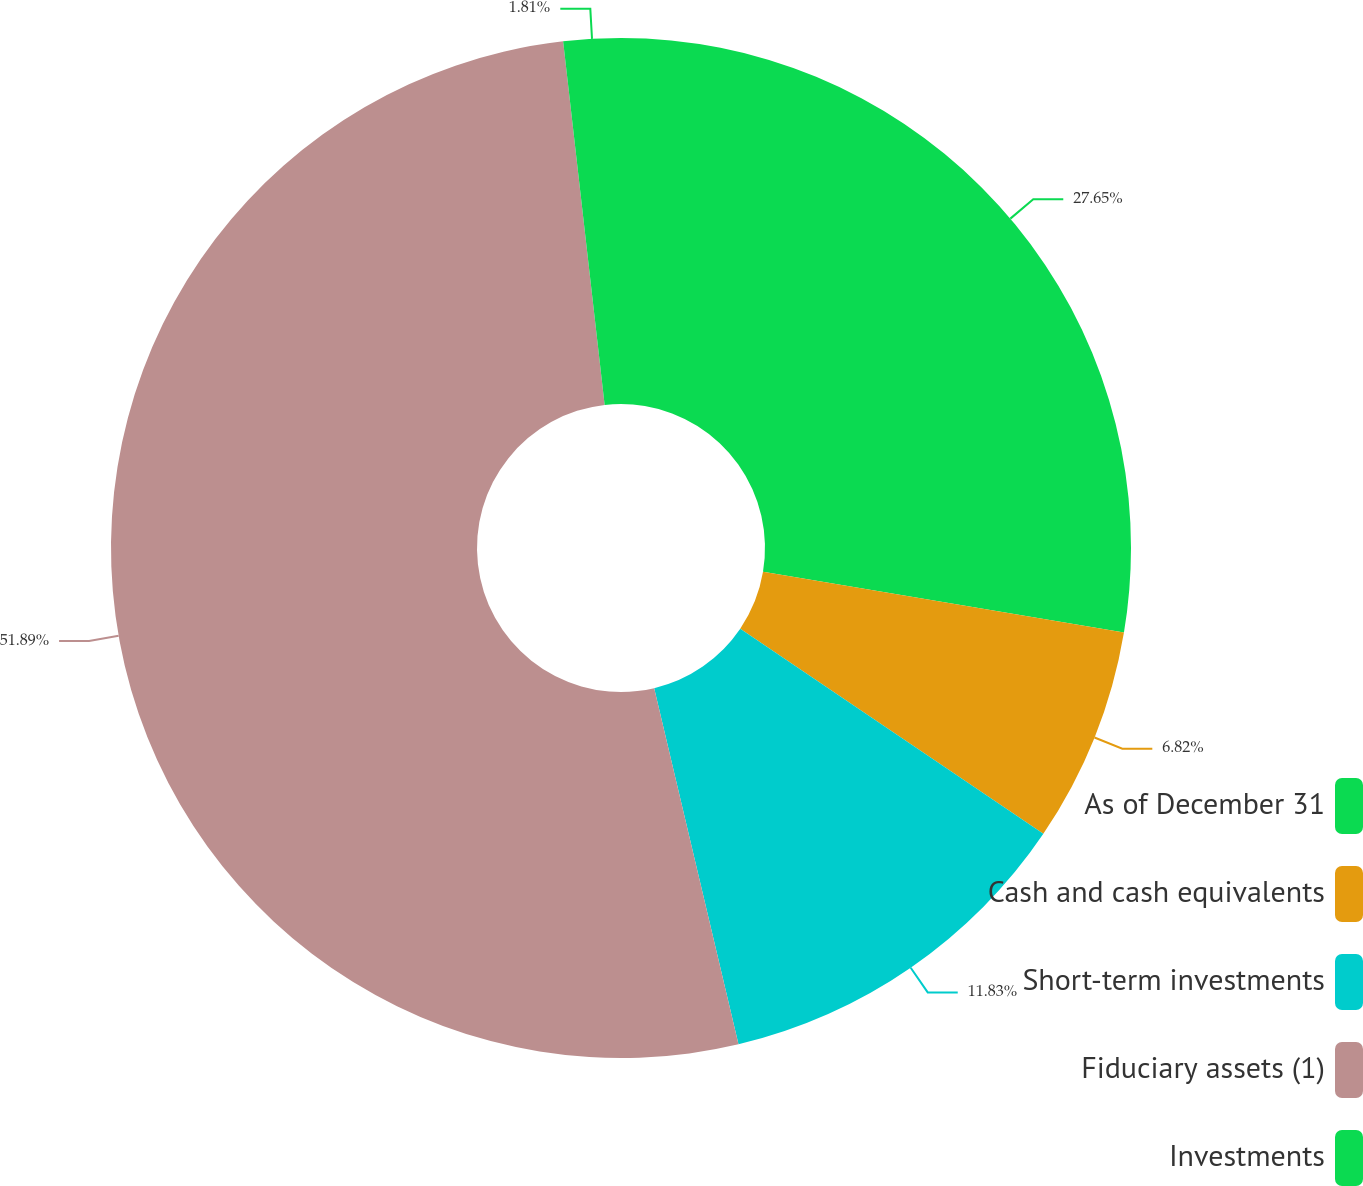<chart> <loc_0><loc_0><loc_500><loc_500><pie_chart><fcel>As of December 31<fcel>Cash and cash equivalents<fcel>Short-term investments<fcel>Fiduciary assets (1)<fcel>Investments<nl><fcel>27.65%<fcel>6.82%<fcel>11.83%<fcel>51.89%<fcel>1.81%<nl></chart> 